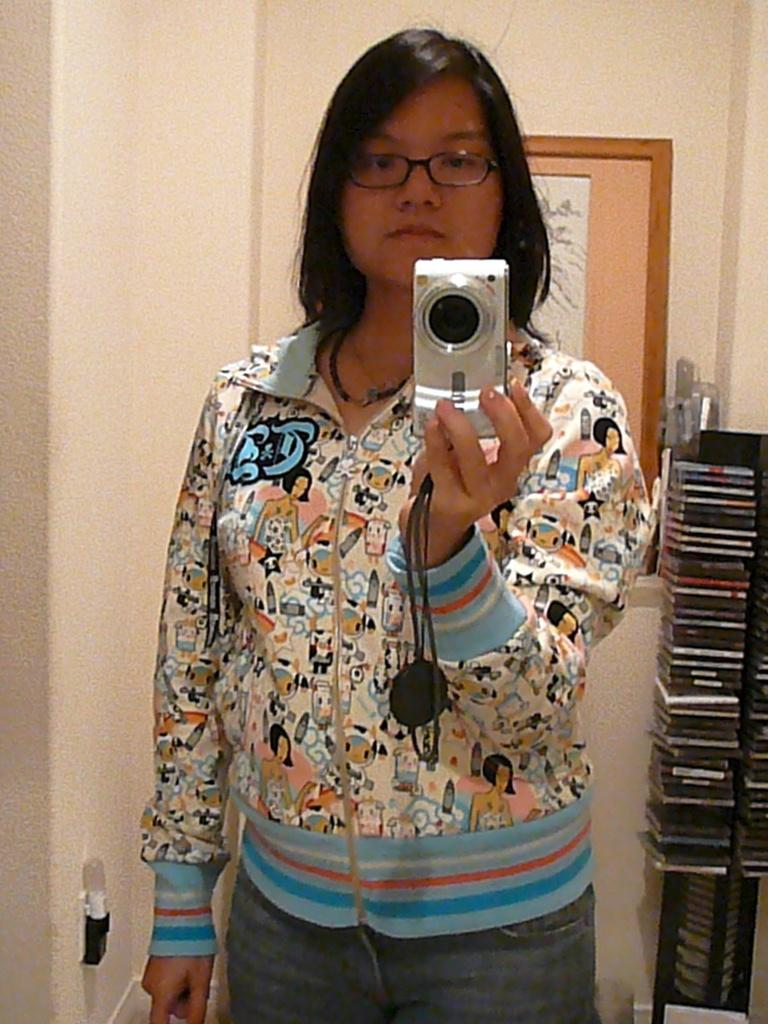Who is the main subject in the image? There is a woman in the image. What is the woman doing in the image? The woman is standing and holding a camera in her hands. What can be seen in the background of the image? There is a wall in the background of the image. Can you describe any specific details on the wall? There is a photo frame on the wall. What type of sign can be seen in the image? There is no sign present in the image. Is there any agreement being made between the woman and another person in the image? There is no indication of an agreement being made in the image. 